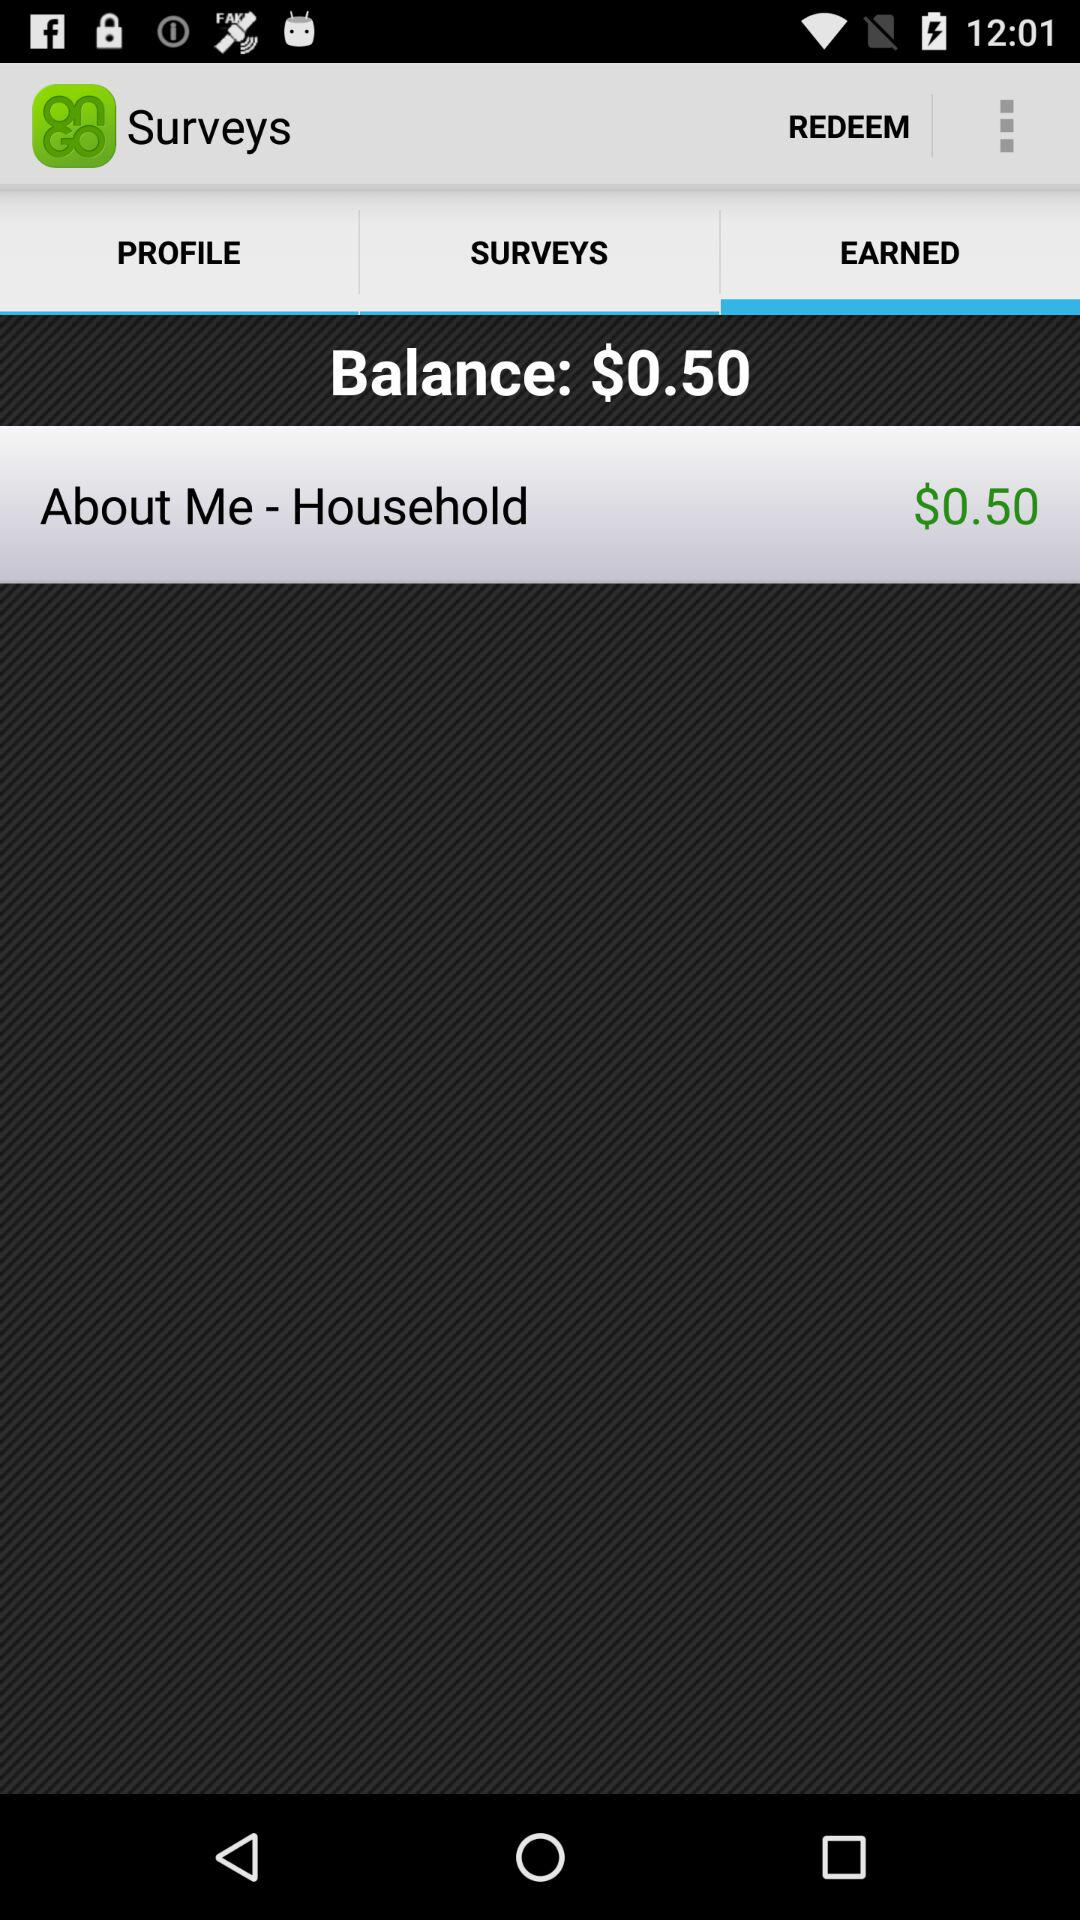Which tab has been selected? The tab that has been selected is "EARNED". 